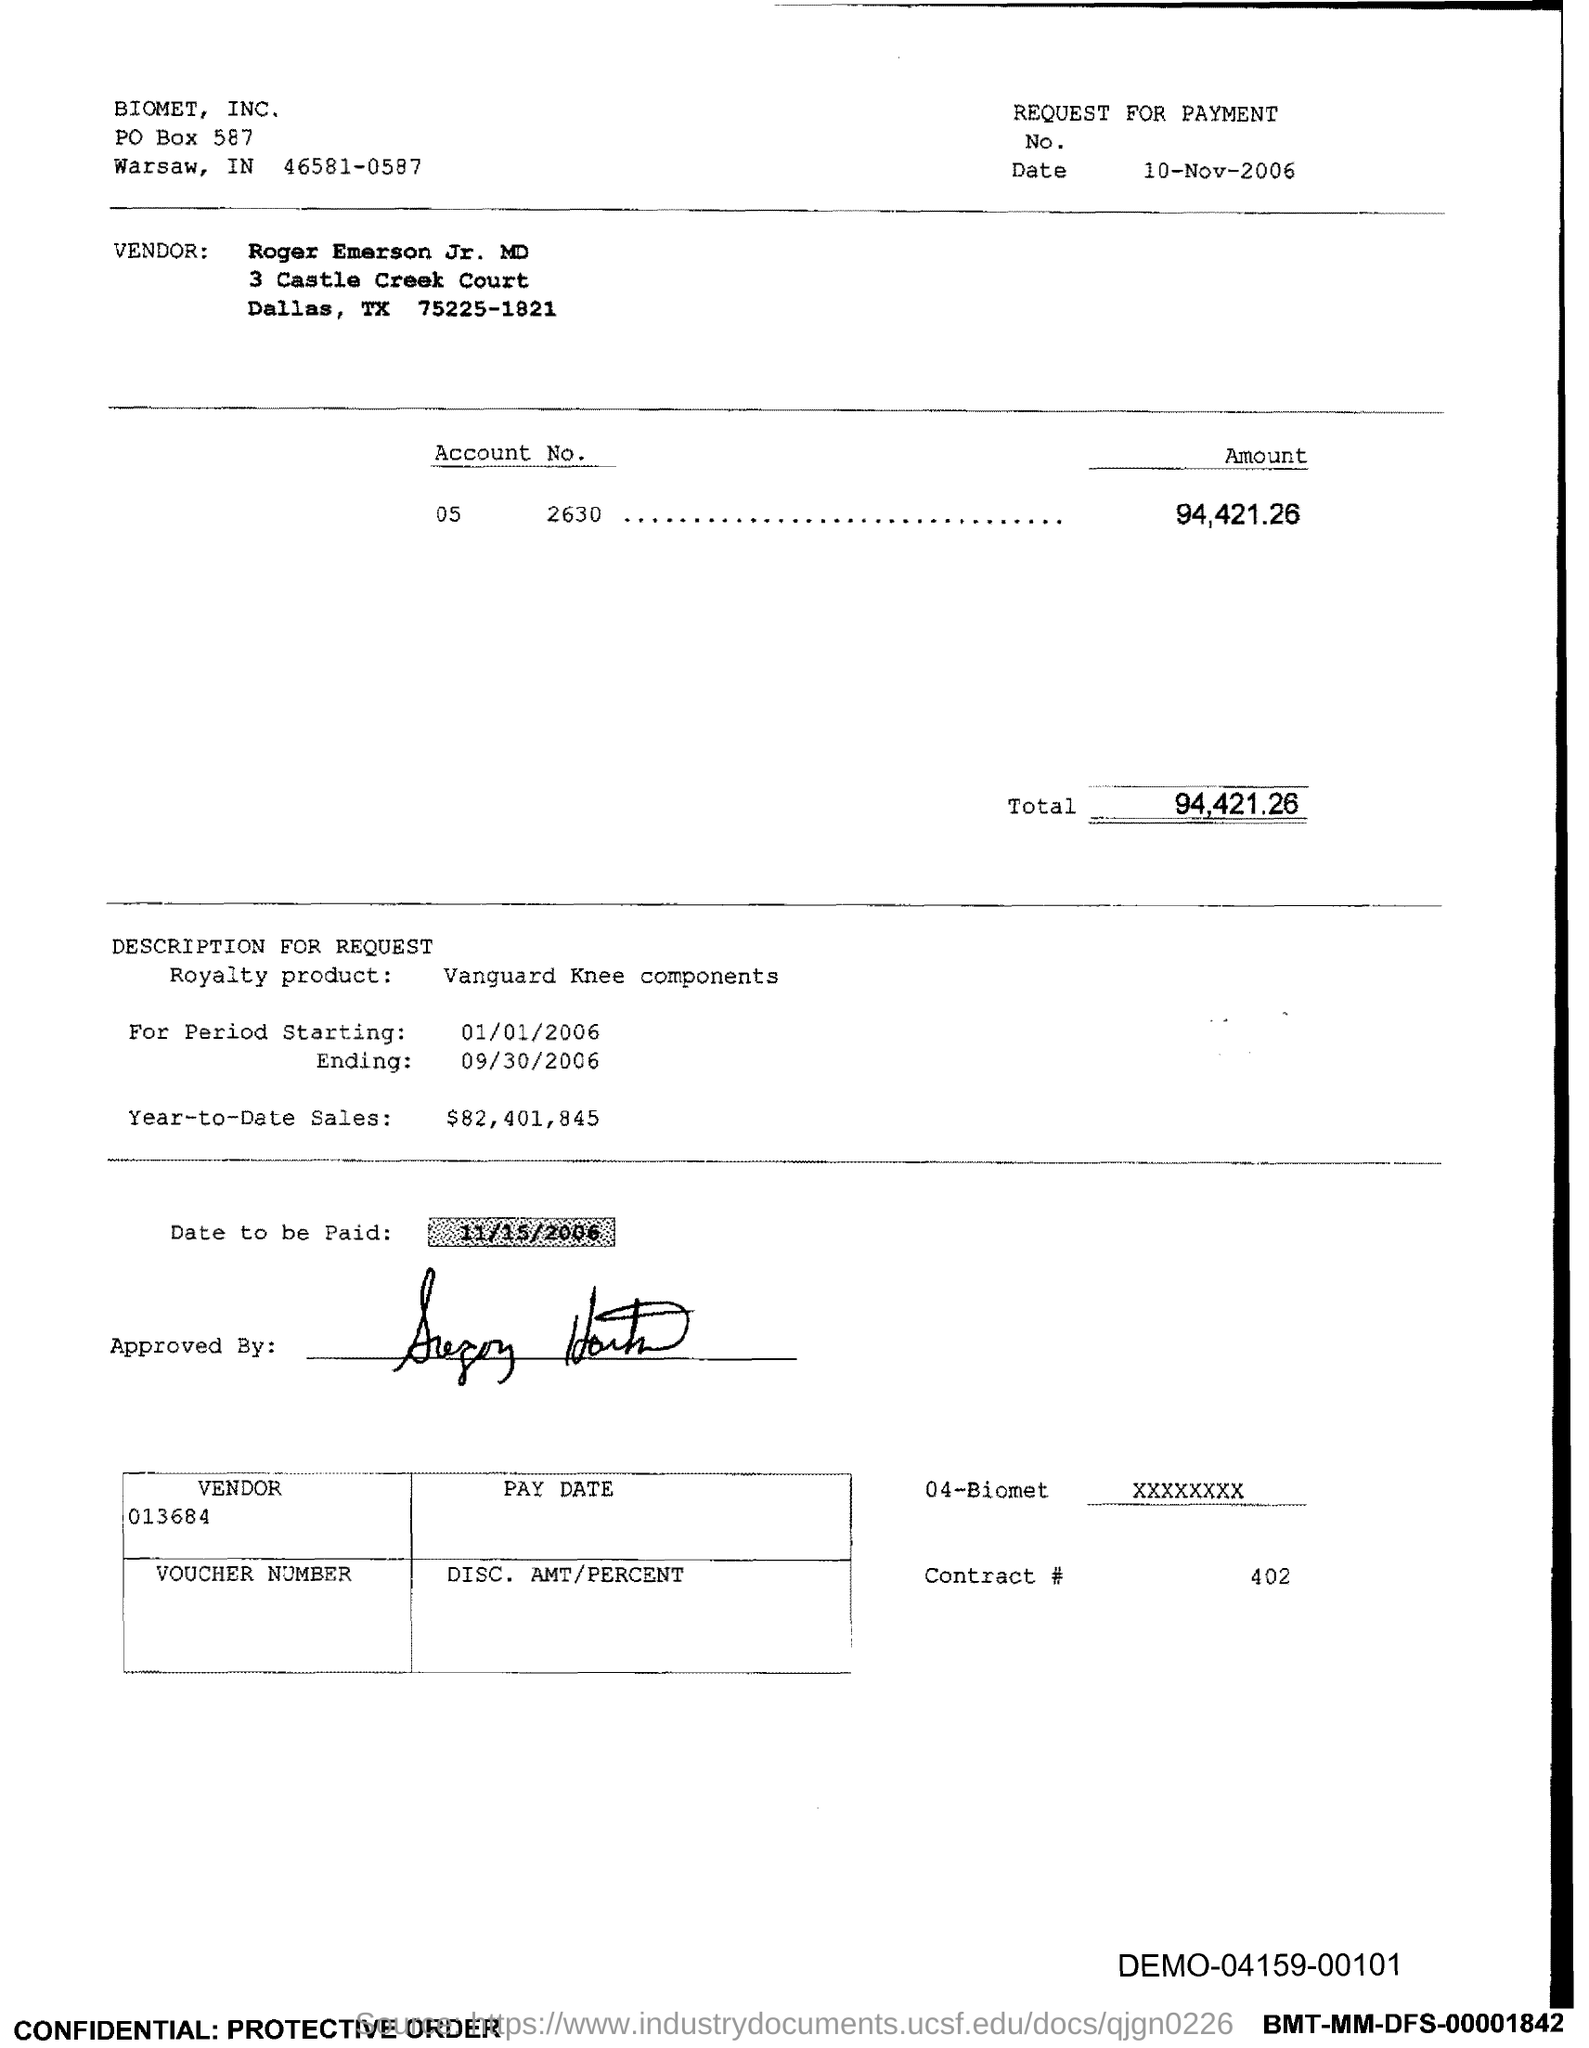Indicate a few pertinent items in this graphic. The PO Box number mentioned in the document is 587. The date to be paid is November 15th, 2006. The total is 94,421.26. 